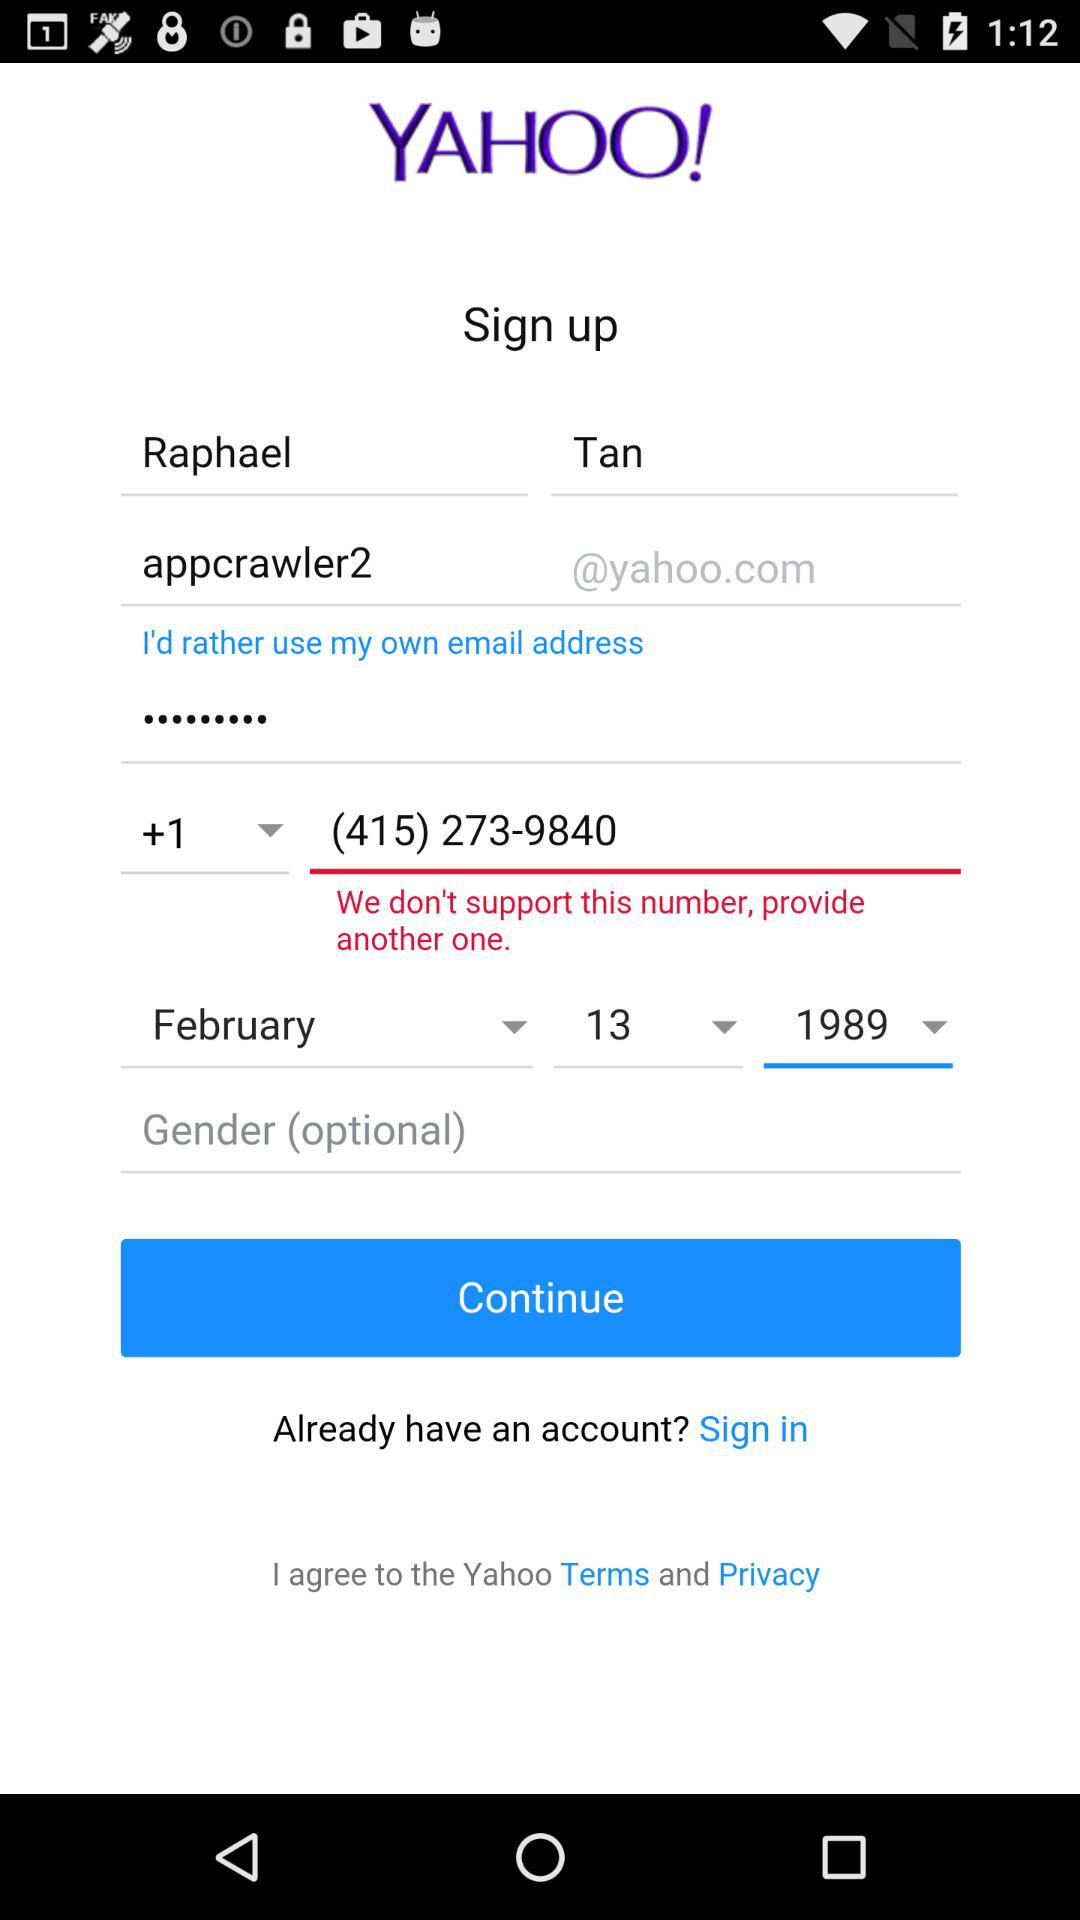What is the email address?
When the provided information is insufficient, respond with <no answer>. <no answer> 